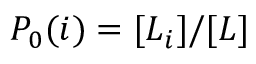Convert formula to latex. <formula><loc_0><loc_0><loc_500><loc_500>P _ { 0 } ( i ) = [ L _ { i } ] / [ L ]</formula> 